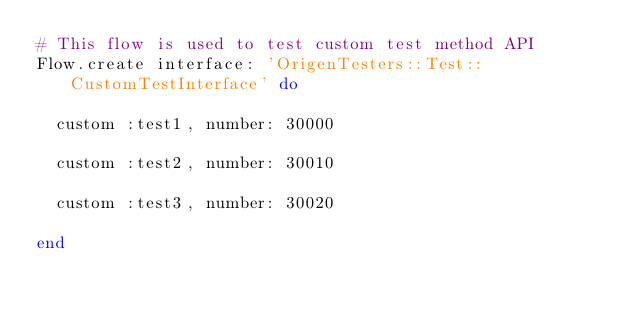<code> <loc_0><loc_0><loc_500><loc_500><_Ruby_># This flow is used to test custom test method API
Flow.create interface: 'OrigenTesters::Test::CustomTestInterface' do

  custom :test1, number: 30000

  custom :test2, number: 30010

  custom :test3, number: 30020

end
</code> 